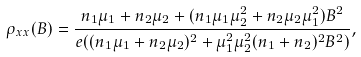Convert formula to latex. <formula><loc_0><loc_0><loc_500><loc_500>\rho _ { x x } ( B ) = \frac { n _ { 1 } \mu _ { 1 } + n _ { 2 } \mu _ { 2 } + ( n _ { 1 } \mu _ { 1 } \mu _ { 2 } ^ { 2 } + n _ { 2 } \mu _ { 2 } \mu _ { 1 } ^ { 2 } ) B ^ { 2 } } { e ( ( n _ { 1 } \mu _ { 1 } + n _ { 2 } \mu _ { 2 } ) ^ { 2 } + \mu _ { 1 } ^ { 2 } \mu _ { 2 } ^ { 2 } ( n _ { 1 } + n _ { 2 } ) ^ { 2 } B ^ { 2 } ) } ,</formula> 